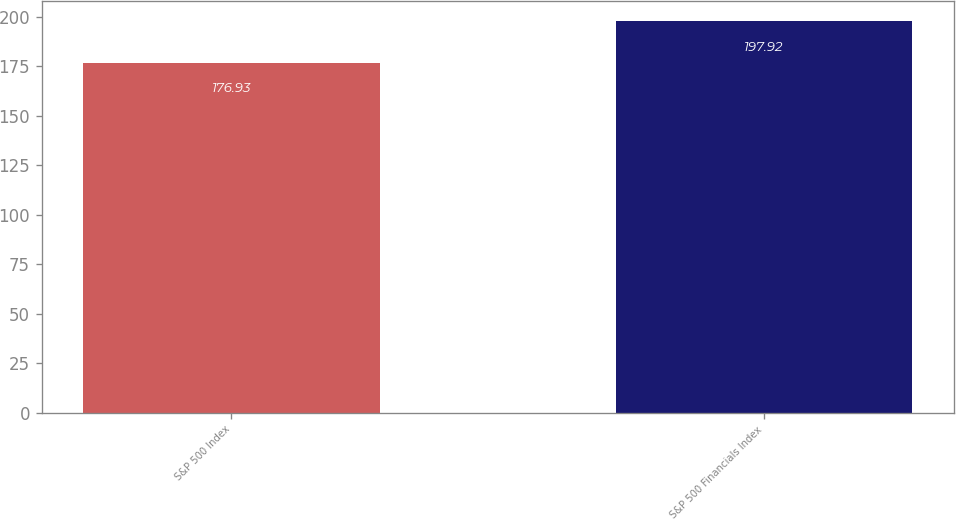Convert chart to OTSL. <chart><loc_0><loc_0><loc_500><loc_500><bar_chart><fcel>S&P 500 Index<fcel>S&P 500 Financials Index<nl><fcel>176.93<fcel>197.92<nl></chart> 